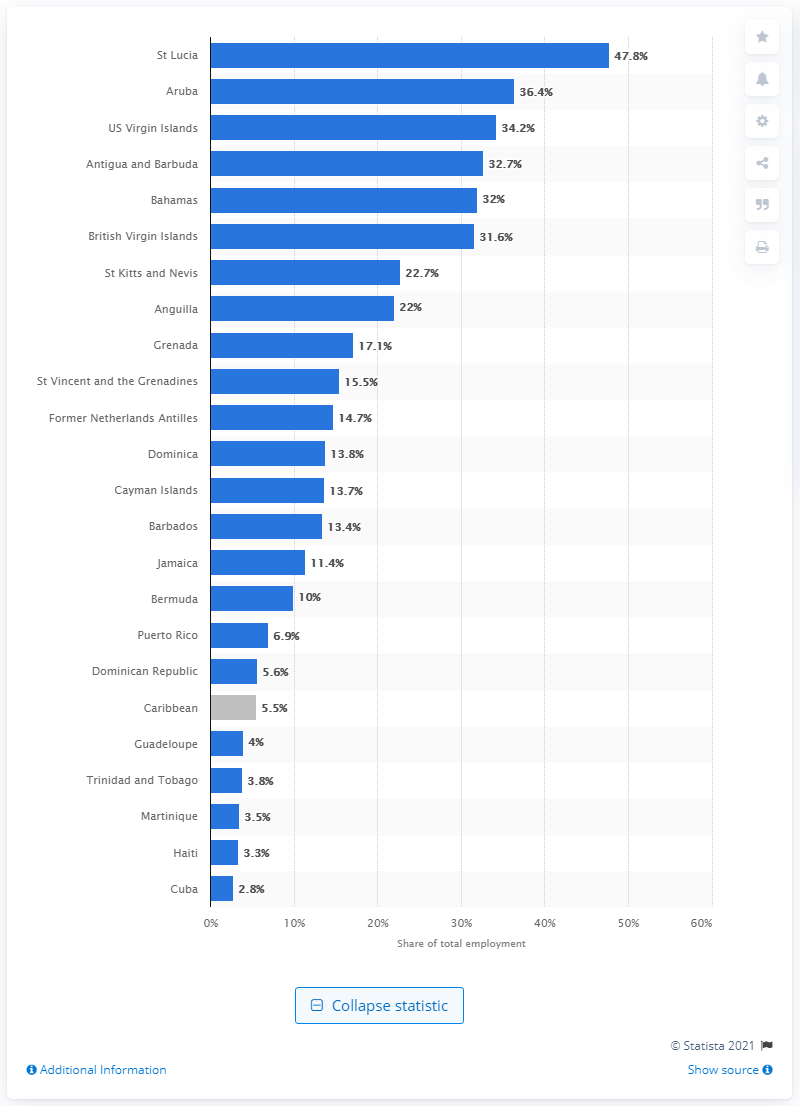Specify some key components in this picture. In 2019, the direct contribution of the travel and tourism sector to total employment in the Caribbean region was 5.5%. 